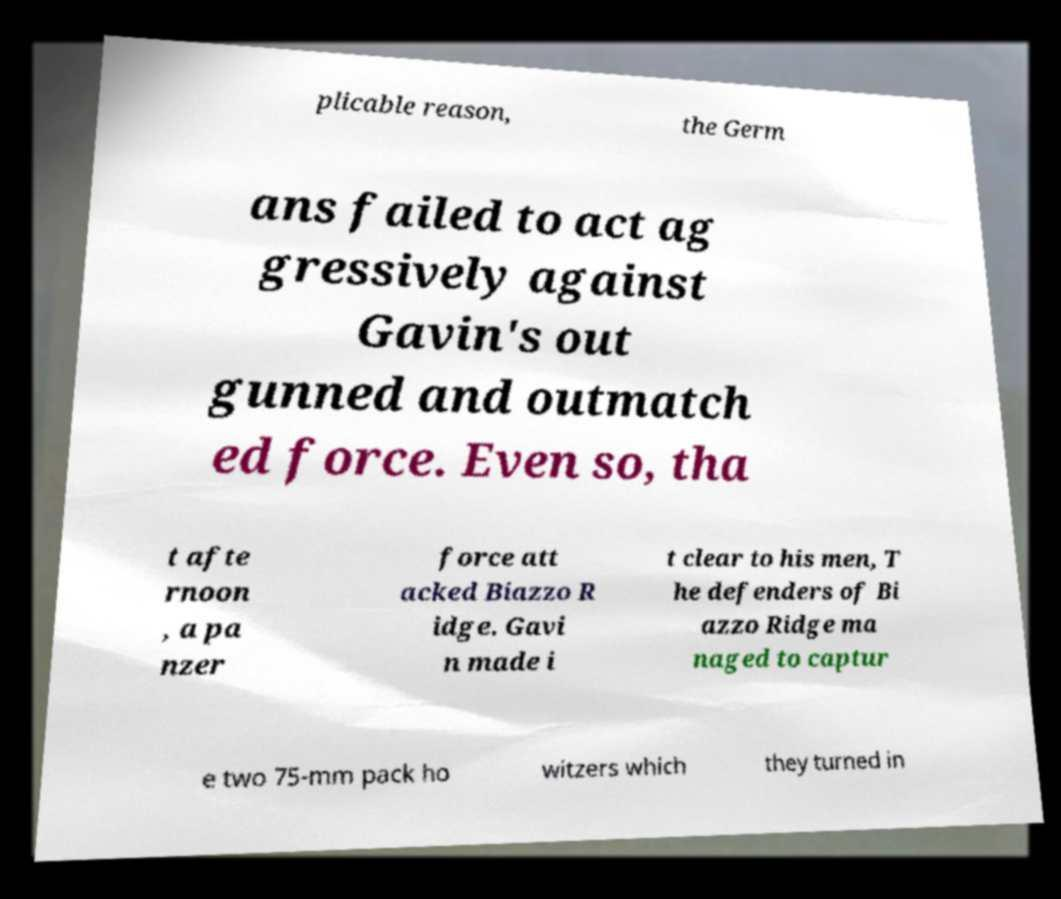Could you assist in decoding the text presented in this image and type it out clearly? plicable reason, the Germ ans failed to act ag gressively against Gavin's out gunned and outmatch ed force. Even so, tha t afte rnoon , a pa nzer force att acked Biazzo R idge. Gavi n made i t clear to his men, T he defenders of Bi azzo Ridge ma naged to captur e two 75-mm pack ho witzers which they turned in 